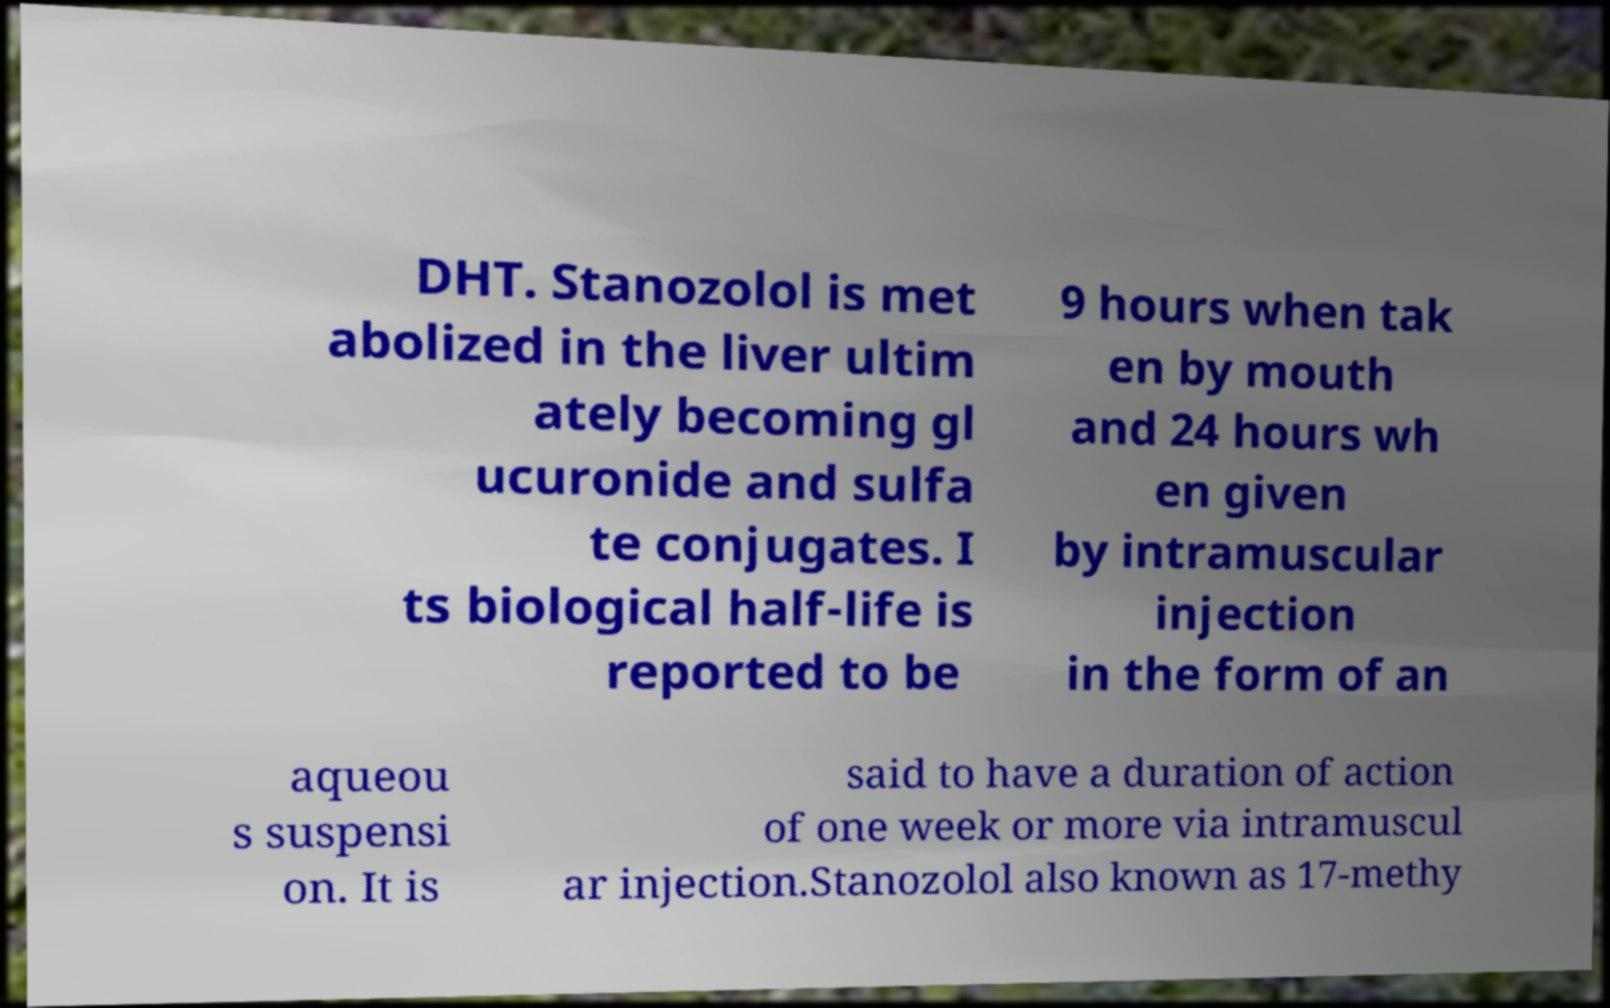Please identify and transcribe the text found in this image. DHT. Stanozolol is met abolized in the liver ultim ately becoming gl ucuronide and sulfa te conjugates. I ts biological half-life is reported to be 9 hours when tak en by mouth and 24 hours wh en given by intramuscular injection in the form of an aqueou s suspensi on. It is said to have a duration of action of one week or more via intramuscul ar injection.Stanozolol also known as 17-methy 